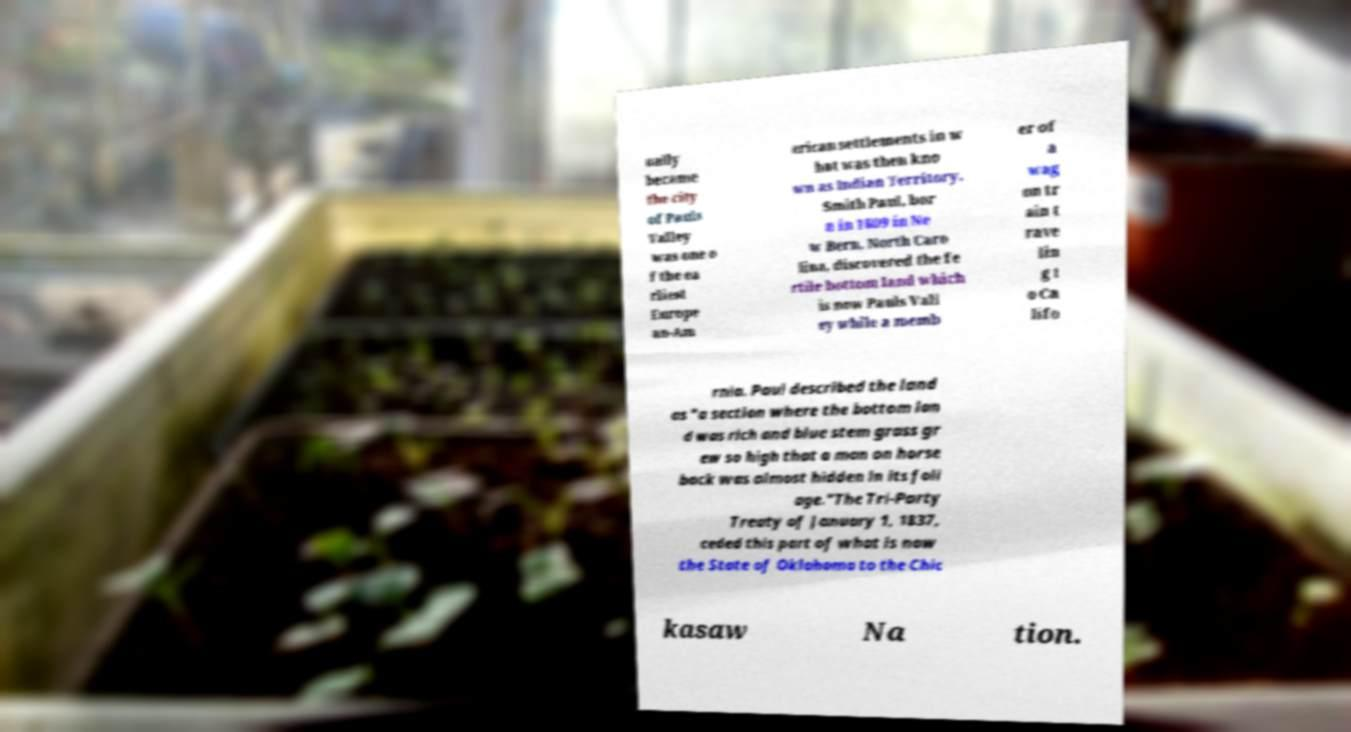Could you extract and type out the text from this image? ually became the city of Pauls Valley was one o f the ea rliest Europe an-Am erican settlements in w hat was then kno wn as Indian Territory. Smith Paul, bor n in 1809 in Ne w Bern, North Caro lina, discovered the fe rtile bottom land which is now Pauls Vall ey while a memb er of a wag on tr ain t rave lin g t o Ca lifo rnia. Paul described the land as "a section where the bottom lan d was rich and blue stem grass gr ew so high that a man on horse back was almost hidden in its foli age."The Tri-Party Treaty of January 1, 1837, ceded this part of what is now the State of Oklahoma to the Chic kasaw Na tion. 